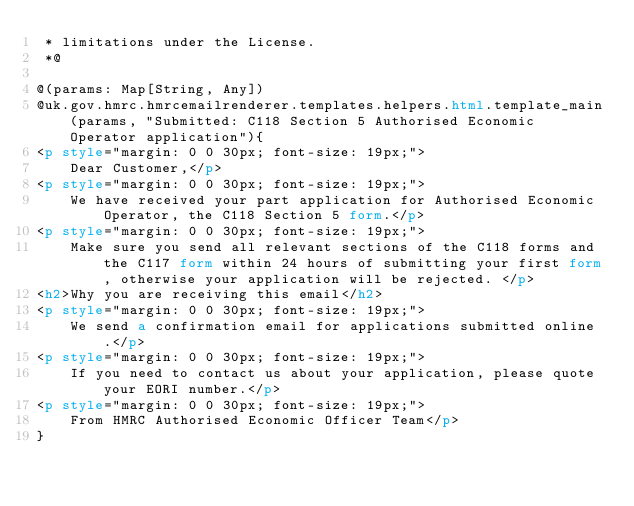<code> <loc_0><loc_0><loc_500><loc_500><_HTML_> * limitations under the License.
 *@

@(params: Map[String, Any])
@uk.gov.hmrc.hmrcemailrenderer.templates.helpers.html.template_main(params, "Submitted: C118 Section 5 Authorised Economic Operator application"){
<p style="margin: 0 0 30px; font-size: 19px;">
    Dear Customer,</p>
<p style="margin: 0 0 30px; font-size: 19px;">
    We have received your part application for Authorised Economic Operator, the C118 Section 5 form.</p>
<p style="margin: 0 0 30px; font-size: 19px;">
    Make sure you send all relevant sections of the C118 forms and the C117 form within 24 hours of submitting your first form, otherwise your application will be rejected. </p>
<h2>Why you are receiving this email</h2>
<p style="margin: 0 0 30px; font-size: 19px;">
    We send a confirmation email for applications submitted online.</p>
<p style="margin: 0 0 30px; font-size: 19px;">
    If you need to contact us about your application, please quote your EORI number.</p>
<p style="margin: 0 0 30px; font-size: 19px;">
    From HMRC Authorised Economic Officer Team</p>
}
</code> 